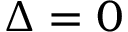<formula> <loc_0><loc_0><loc_500><loc_500>\Delta = 0</formula> 